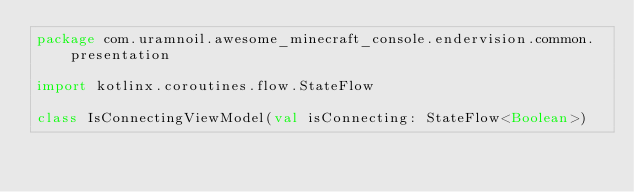Convert code to text. <code><loc_0><loc_0><loc_500><loc_500><_Kotlin_>package com.uramnoil.awesome_minecraft_console.endervision.common.presentation

import kotlinx.coroutines.flow.StateFlow

class IsConnectingViewModel(val isConnecting: StateFlow<Boolean>)</code> 